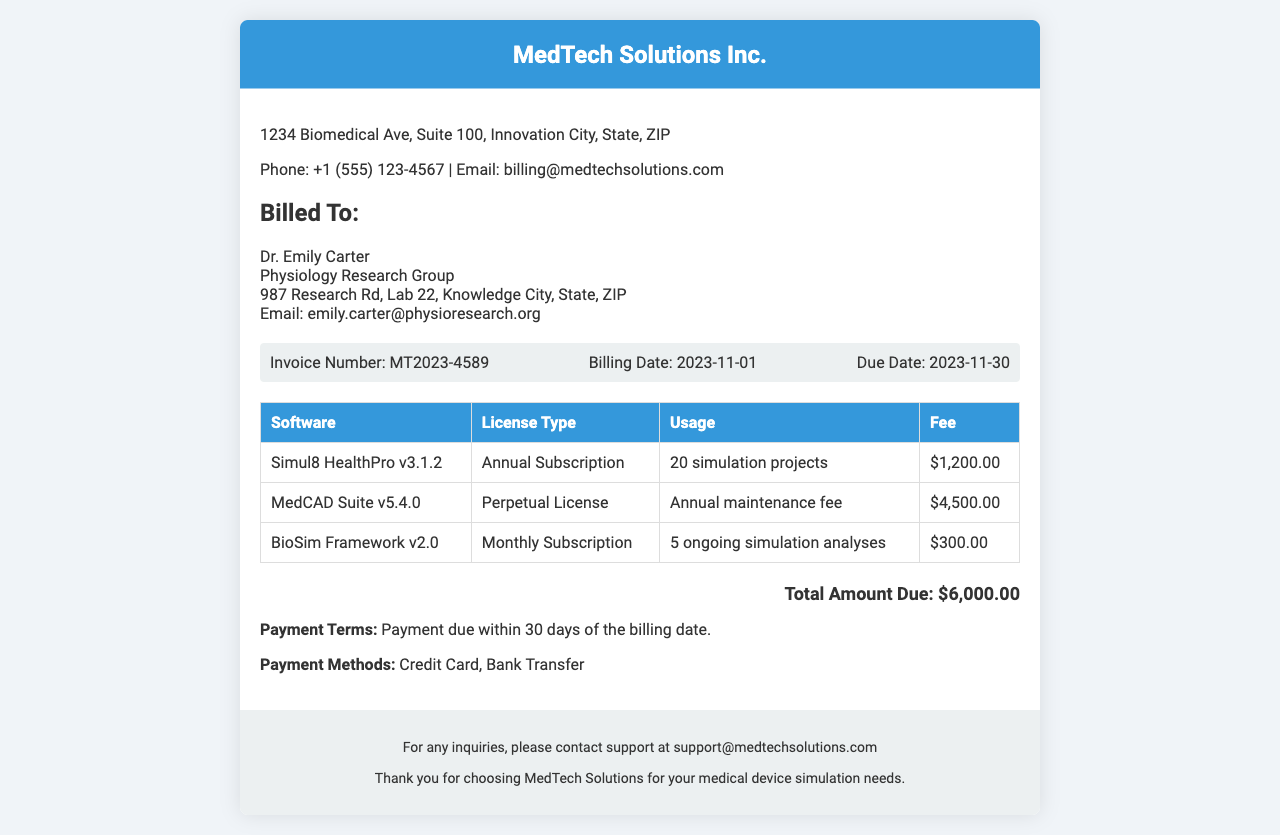What is the company name? The company name is listed at the top of the document in the header section.
Answer: MedTech Solutions Inc What is the total amount due? The total amount due is provided in the total section of the document.
Answer: $6,000.00 What is the billing date? The billing date is mentioned under the invoice details in the document.
Answer: 2023-11-01 What is the due date? The due date is provided alongside the billing date in the invoice details section.
Answer: 2023-11-30 How many simulation projects were used for Simul8 HealthPro? The usage details are included in the table for each software listed in the document.
Answer: 20 simulation projects What payment methods are accepted? The payment methods are detailed in the content section of the document.
Answer: Credit Card, Bank Transfer What type of license is MedCAD Suite? The license type for each software is specified in the table.
Answer: Perpetual License How many ongoing simulation analyses are conducted with BioSim Framework? The usage of BioSim Framework is specified in the table regarding ongoing analyses.
Answer: 5 ongoing simulation analyses What is the invoice number? The invoice number is displayed in the invoice details section of the document.
Answer: MT2023-4589 What is the annual maintenance fee for MedCAD Suite? The fee for MedCAD Suite is included in the respective row of the table.
Answer: $4,500.00 